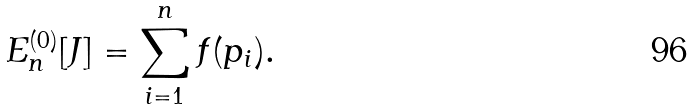<formula> <loc_0><loc_0><loc_500><loc_500>E ^ { ( 0 ) } _ { n } [ J ] = \sum _ { i = 1 } ^ { n } f ( p _ { i } ) .</formula> 